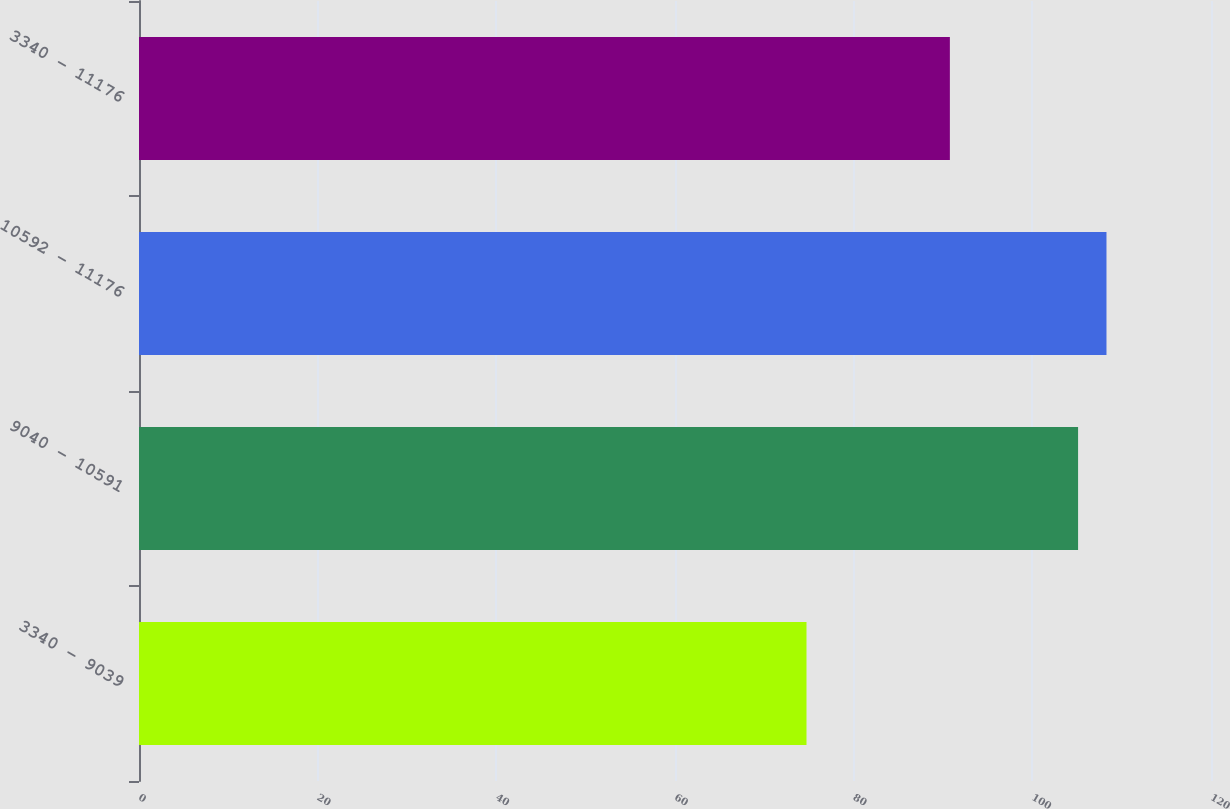Convert chart to OTSL. <chart><loc_0><loc_0><loc_500><loc_500><bar_chart><fcel>3340 - 9039<fcel>9040 - 10591<fcel>10592 - 11176<fcel>3340 - 11176<nl><fcel>74.72<fcel>105.12<fcel>108.3<fcel>90.77<nl></chart> 